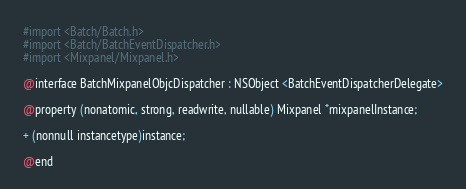Convert code to text. <code><loc_0><loc_0><loc_500><loc_500><_C_>#import <Batch/Batch.h>
#import <Batch/BatchEventDispatcher.h>
#import <Mixpanel/Mixpanel.h>

@interface BatchMixpanelObjcDispatcher : NSObject <BatchEventDispatcherDelegate>

@property (nonatomic, strong, readwrite, nullable) Mixpanel *mixpanelInstance;

+ (nonnull instancetype)instance;

@end
</code> 